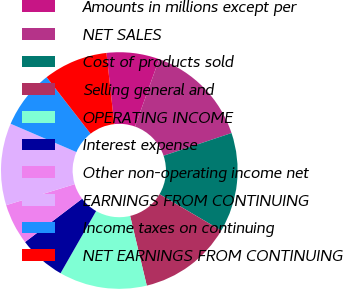<chart> <loc_0><loc_0><loc_500><loc_500><pie_chart><fcel>Amounts in millions except per<fcel>NET SALES<fcel>Cost of products sold<fcel>Selling general and<fcel>OPERATING INCOME<fcel>Interest expense<fcel>Other non-operating income net<fcel>EARNINGS FROM CONTINUING<fcel>Income taxes on continuing<fcel>NET EARNINGS FROM CONTINUING<nl><fcel>7.2%<fcel>14.4%<fcel>13.6%<fcel>12.8%<fcel>12.0%<fcel>6.4%<fcel>5.6%<fcel>11.2%<fcel>8.0%<fcel>8.8%<nl></chart> 